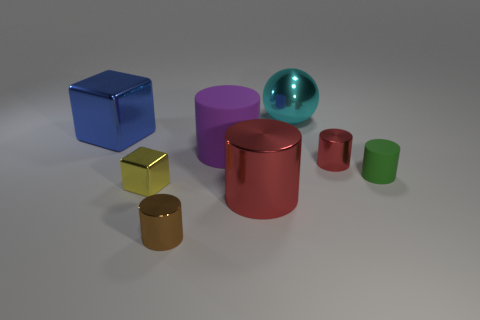Add 1 big yellow objects. How many objects exist? 9 Subtract all purple matte cylinders. How many cylinders are left? 4 Subtract 0 brown cubes. How many objects are left? 8 Subtract all cubes. How many objects are left? 6 Subtract 3 cylinders. How many cylinders are left? 2 Subtract all cyan cylinders. Subtract all blue cubes. How many cylinders are left? 5 Subtract all brown blocks. How many blue cylinders are left? 0 Subtract all large gray cylinders. Subtract all big blue metallic objects. How many objects are left? 7 Add 7 large rubber things. How many large rubber things are left? 8 Add 1 red metal objects. How many red metal objects exist? 3 